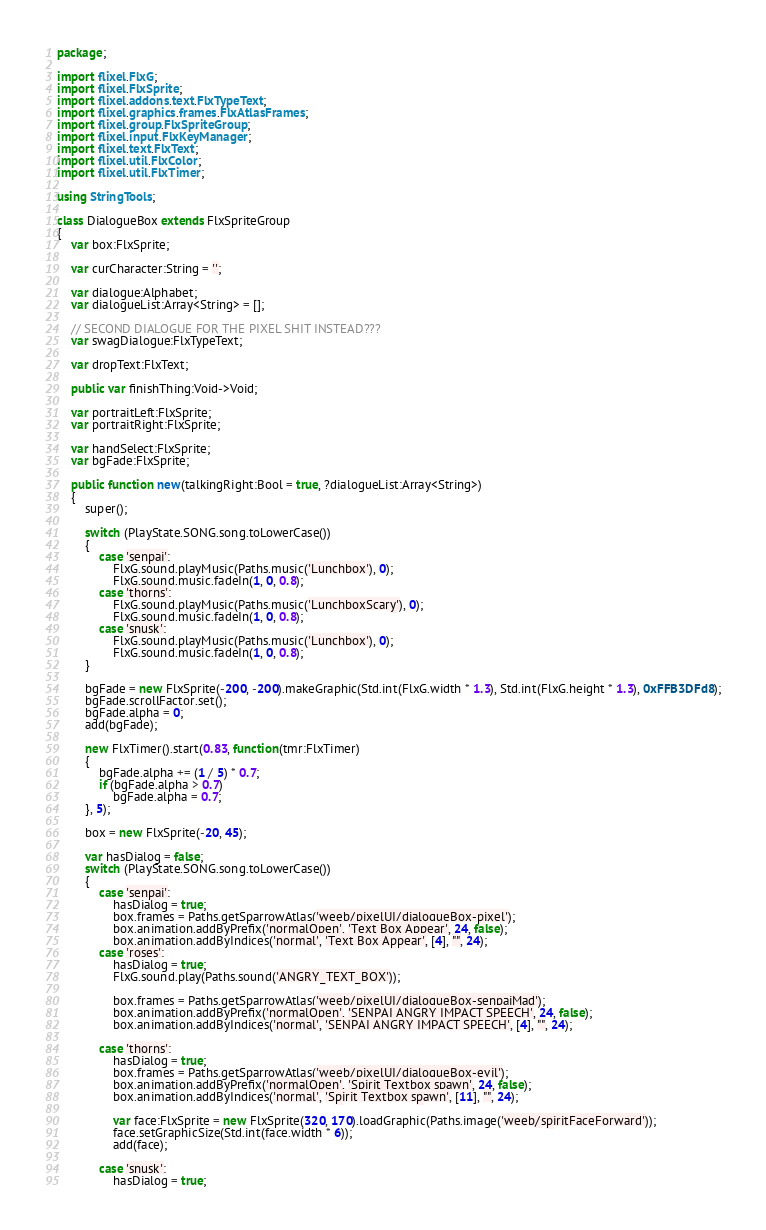<code> <loc_0><loc_0><loc_500><loc_500><_Haxe_>package;

import flixel.FlxG;
import flixel.FlxSprite;
import flixel.addons.text.FlxTypeText;
import flixel.graphics.frames.FlxAtlasFrames;
import flixel.group.FlxSpriteGroup;
import flixel.input.FlxKeyManager;
import flixel.text.FlxText;
import flixel.util.FlxColor;
import flixel.util.FlxTimer;

using StringTools;

class DialogueBox extends FlxSpriteGroup
{
	var box:FlxSprite;

	var curCharacter:String = '';

	var dialogue:Alphabet;
	var dialogueList:Array<String> = [];

	// SECOND DIALOGUE FOR THE PIXEL SHIT INSTEAD???
	var swagDialogue:FlxTypeText;

	var dropText:FlxText;

	public var finishThing:Void->Void;

	var portraitLeft:FlxSprite;
	var portraitRight:FlxSprite;

	var handSelect:FlxSprite;
	var bgFade:FlxSprite;

	public function new(talkingRight:Bool = true, ?dialogueList:Array<String>)
	{
		super();

		switch (PlayState.SONG.song.toLowerCase())
		{
			case 'senpai':
				FlxG.sound.playMusic(Paths.music('Lunchbox'), 0);
				FlxG.sound.music.fadeIn(1, 0, 0.8);
			case 'thorns':
				FlxG.sound.playMusic(Paths.music('LunchboxScary'), 0);
				FlxG.sound.music.fadeIn(1, 0, 0.8);
			case 'snusk':
				FlxG.sound.playMusic(Paths.music('Lunchbox'), 0);
				FlxG.sound.music.fadeIn(1, 0, 0.8);
		}

		bgFade = new FlxSprite(-200, -200).makeGraphic(Std.int(FlxG.width * 1.3), Std.int(FlxG.height * 1.3), 0xFFB3DFd8);
		bgFade.scrollFactor.set();
		bgFade.alpha = 0;
		add(bgFade);

		new FlxTimer().start(0.83, function(tmr:FlxTimer)
		{
			bgFade.alpha += (1 / 5) * 0.7;
			if (bgFade.alpha > 0.7)
				bgFade.alpha = 0.7;
		}, 5);

		box = new FlxSprite(-20, 45);
		
		var hasDialog = false;
		switch (PlayState.SONG.song.toLowerCase())
		{
			case 'senpai':
				hasDialog = true;
				box.frames = Paths.getSparrowAtlas('weeb/pixelUI/dialogueBox-pixel');
				box.animation.addByPrefix('normalOpen', 'Text Box Appear', 24, false);
				box.animation.addByIndices('normal', 'Text Box Appear', [4], "", 24);
			case 'roses':
				hasDialog = true;
				FlxG.sound.play(Paths.sound('ANGRY_TEXT_BOX'));

				box.frames = Paths.getSparrowAtlas('weeb/pixelUI/dialogueBox-senpaiMad');
				box.animation.addByPrefix('normalOpen', 'SENPAI ANGRY IMPACT SPEECH', 24, false);
				box.animation.addByIndices('normal', 'SENPAI ANGRY IMPACT SPEECH', [4], "", 24);

			case 'thorns':
				hasDialog = true;
				box.frames = Paths.getSparrowAtlas('weeb/pixelUI/dialogueBox-evil');
				box.animation.addByPrefix('normalOpen', 'Spirit Textbox spawn', 24, false);
				box.animation.addByIndices('normal', 'Spirit Textbox spawn', [11], "", 24);

				var face:FlxSprite = new FlxSprite(320, 170).loadGraphic(Paths.image('weeb/spiritFaceForward'));
				face.setGraphicSize(Std.int(face.width * 6));
				add(face);

			case 'snusk':
				hasDialog = true;</code> 